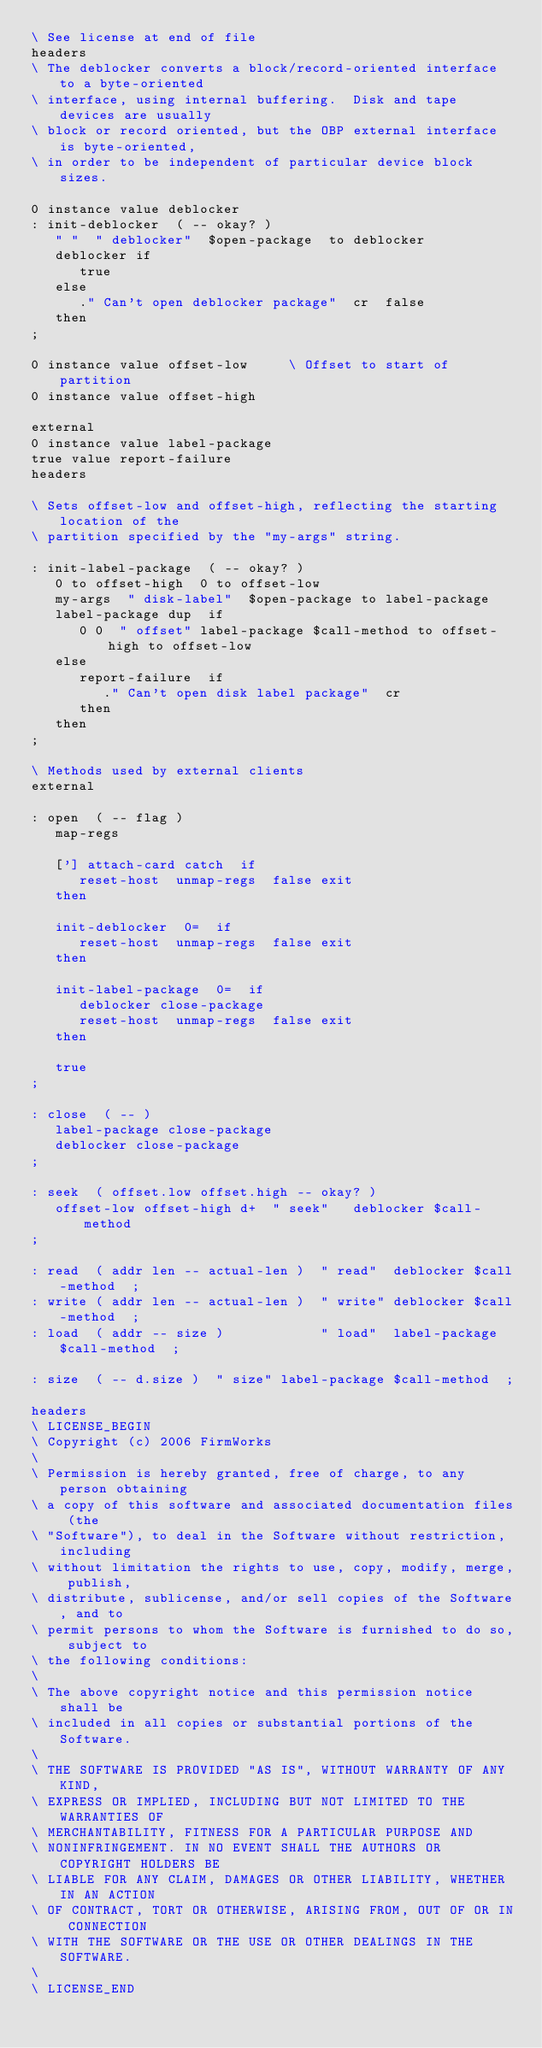<code> <loc_0><loc_0><loc_500><loc_500><_Forth_>\ See license at end of file
headers
\ The deblocker converts a block/record-oriented interface to a byte-oriented
\ interface, using internal buffering.  Disk and tape devices are usually
\ block or record oriented, but the OBP external interface is byte-oriented,
\ in order to be independent of particular device block sizes.

0 instance value deblocker
: init-deblocker  ( -- okay? )
   " "  " deblocker"  $open-package  to deblocker
   deblocker if
      true
   else
      ." Can't open deblocker package"  cr  false
   then
;

0 instance value offset-low     \ Offset to start of partition
0 instance value offset-high

external
0 instance value label-package
true value report-failure
headers

\ Sets offset-low and offset-high, reflecting the starting location of the
\ partition specified by the "my-args" string.

: init-label-package  ( -- okay? )
   0 to offset-high  0 to offset-low
   my-args  " disk-label"  $open-package to label-package
   label-package dup  if
      0 0  " offset" label-package $call-method to offset-high to offset-low
   else
      report-failure  if
         ." Can't open disk label package"  cr
      then
   then
;

\ Methods used by external clients
external

: open  ( -- flag )
   map-regs

   ['] attach-card catch  if
      reset-host  unmap-regs  false exit
   then

   init-deblocker  0=  if
      reset-host  unmap-regs  false exit
   then

   init-label-package  0=  if
      deblocker close-package
      reset-host  unmap-regs  false exit
   then

   true
;

: close  ( -- )
   label-package close-package
   deblocker close-package
;

: seek  ( offset.low offset.high -- okay? )
   offset-low offset-high d+  " seek"   deblocker $call-method
;

: read  ( addr len -- actual-len )  " read"  deblocker $call-method  ;
: write ( addr len -- actual-len )  " write" deblocker $call-method  ;
: load  ( addr -- size )            " load"  label-package $call-method  ;

: size  ( -- d.size )  " size" label-package $call-method  ;

headers
\ LICENSE_BEGIN
\ Copyright (c) 2006 FirmWorks
\ 
\ Permission is hereby granted, free of charge, to any person obtaining
\ a copy of this software and associated documentation files (the
\ "Software"), to deal in the Software without restriction, including
\ without limitation the rights to use, copy, modify, merge, publish,
\ distribute, sublicense, and/or sell copies of the Software, and to
\ permit persons to whom the Software is furnished to do so, subject to
\ the following conditions:
\ 
\ The above copyright notice and this permission notice shall be
\ included in all copies or substantial portions of the Software.
\ 
\ THE SOFTWARE IS PROVIDED "AS IS", WITHOUT WARRANTY OF ANY KIND,
\ EXPRESS OR IMPLIED, INCLUDING BUT NOT LIMITED TO THE WARRANTIES OF
\ MERCHANTABILITY, FITNESS FOR A PARTICULAR PURPOSE AND
\ NONINFRINGEMENT. IN NO EVENT SHALL THE AUTHORS OR COPYRIGHT HOLDERS BE
\ LIABLE FOR ANY CLAIM, DAMAGES OR OTHER LIABILITY, WHETHER IN AN ACTION
\ OF CONTRACT, TORT OR OTHERWISE, ARISING FROM, OUT OF OR IN CONNECTION
\ WITH THE SOFTWARE OR THE USE OR OTHER DEALINGS IN THE SOFTWARE.
\
\ LICENSE_END
</code> 